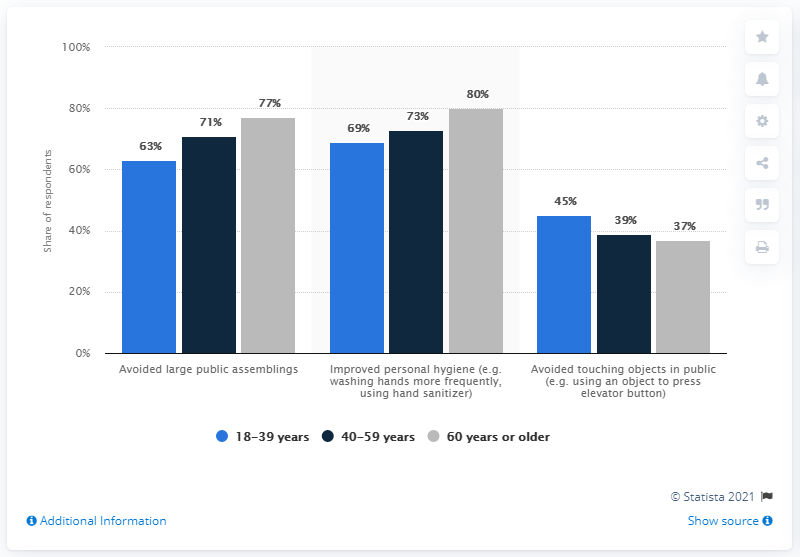List a handful of essential elements in this visual. In the oldest age group, 80% of respondents had this in mind. According to the survey responses, 211 respondents avoided large public assemblies. Grey indicates the age of 60 years or older. 